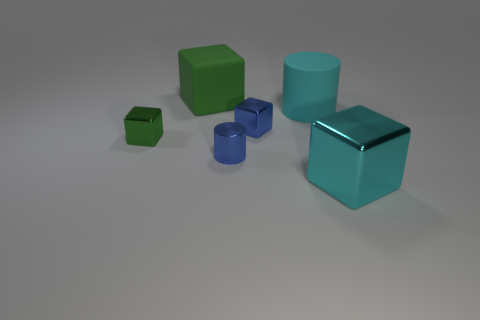Is the large metallic cube the same color as the matte cylinder?
Provide a succinct answer. Yes. The tiny shiny object that is the same color as the big rubber cube is what shape?
Keep it short and to the point. Cube. Do the green cube that is behind the large matte cylinder and the large cyan cylinder have the same material?
Your answer should be very brief. Yes. How big is the green matte object that is behind the cyan metal cube?
Give a very brief answer. Large. Are there any big green rubber cubes on the right side of the cyan thing that is behind the cyan metallic block?
Ensure brevity in your answer.  No. Does the large block behind the cyan shiny thing have the same color as the large block right of the rubber cylinder?
Give a very brief answer. No. What is the color of the rubber cylinder?
Ensure brevity in your answer.  Cyan. Is there anything else that is the same color as the big metallic object?
Ensure brevity in your answer.  Yes. The shiny cube that is both left of the big cyan shiny block and right of the metal cylinder is what color?
Your response must be concise. Blue. Is the size of the cyan object on the left side of the cyan metal object the same as the tiny green shiny object?
Offer a very short reply. No. 